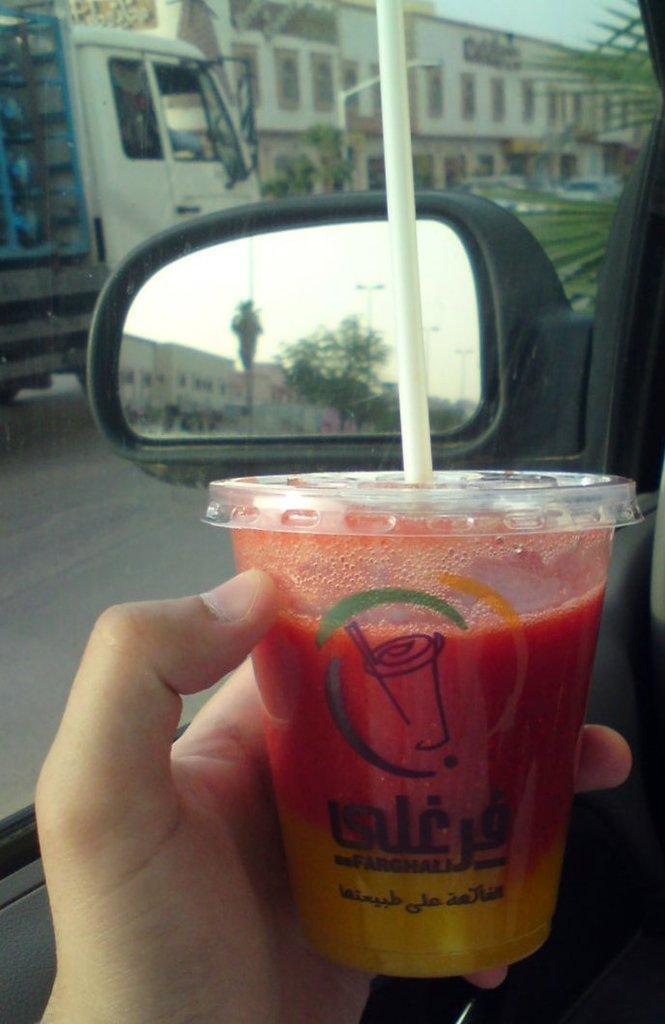In one or two sentences, can you explain what this image depicts? Here a person is holding glass in the hand, here there are trees, here there are vehicles on the road. 